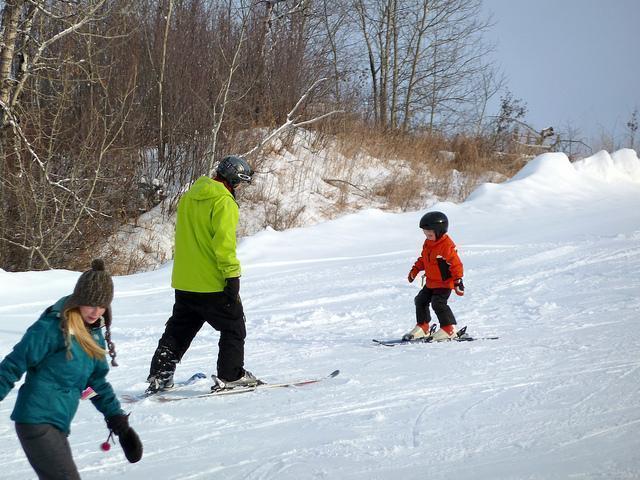The number of people here is called what?
Select the accurate response from the four choices given to answer the question.
Options: Dozen, quartet, quintet, trio. Trio. 